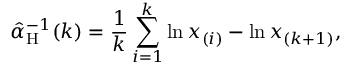<formula> <loc_0><loc_0><loc_500><loc_500>\hat { \alpha } _ { \mathrm H } ^ { - 1 } ( k ) = \frac { 1 } { k } \sum _ { i = 1 } ^ { k } \ln x _ { ( i ) } - \ln x _ { ( k + 1 ) } ,</formula> 